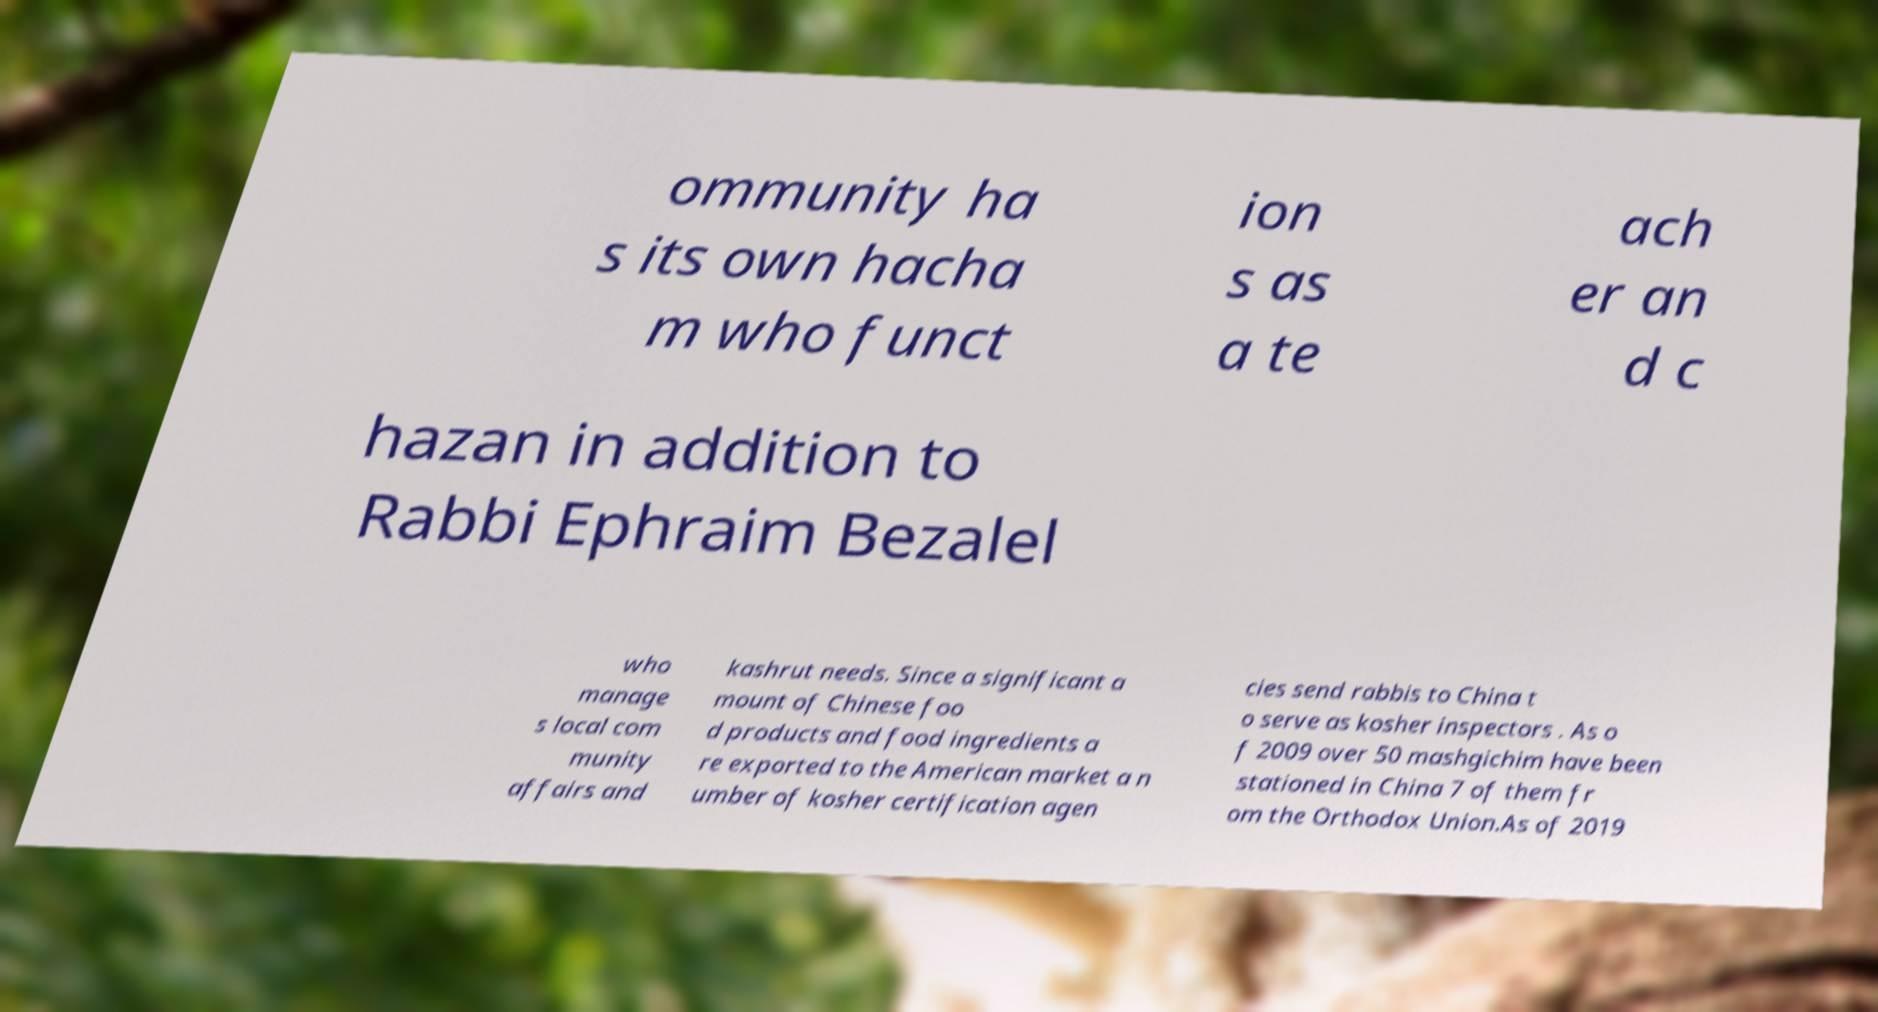Could you assist in decoding the text presented in this image and type it out clearly? ommunity ha s its own hacha m who funct ion s as a te ach er an d c hazan in addition to Rabbi Ephraim Bezalel who manage s local com munity affairs and kashrut needs. Since a significant a mount of Chinese foo d products and food ingredients a re exported to the American market a n umber of kosher certification agen cies send rabbis to China t o serve as kosher inspectors . As o f 2009 over 50 mashgichim have been stationed in China 7 of them fr om the Orthodox Union.As of 2019 